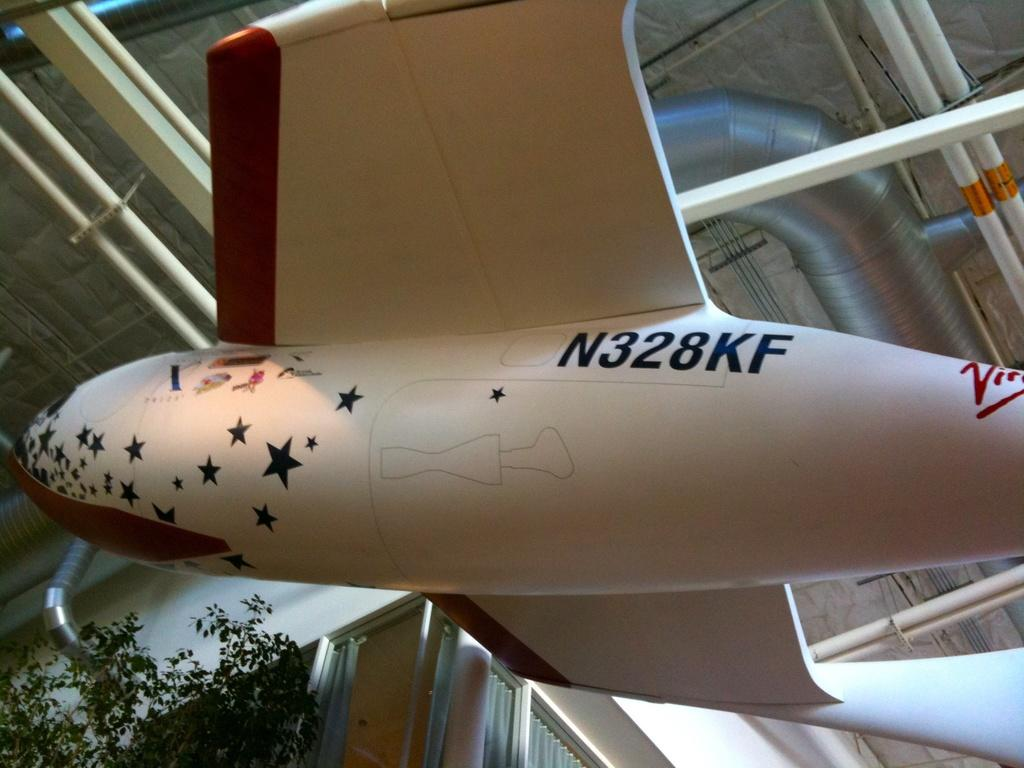What is the main subject of the image? There is an aircraft in the image. Can you describe any text or writing on the aircraft? Something is written on the aircraft. What can be seen to the left of the image? There is a plant to the left of the image. What type of objects are visible at the top of the image? There are pipes visible in the top of the image. What colors are the pipes? The pipes are white and silver in color. How many corn plants are growing on the aircraft in the image? There are no corn plants visible in the image; the only plant mentioned is to the left of the image. What type of ship can be seen sailing in the background of the image? There is no ship present in the image; it features an aircraft and pipes. 